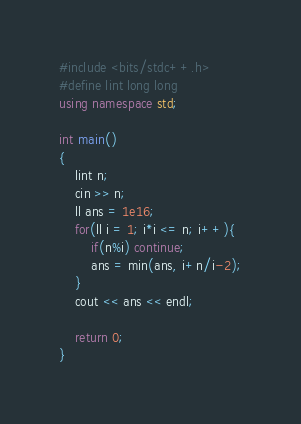Convert code to text. <code><loc_0><loc_0><loc_500><loc_500><_C++_>#include <bits/stdc++.h>
#define lint long long
using namespace std;
 
int main()
{
    lint n;
    cin >> n;
    ll ans = 1e16;
    for(ll i = 1; i*i <= n; i++){
        if(n%i) continue;
        ans = min(ans, i+n/i-2);
    }
    cout << ans << endl;
 
    return 0;
}
</code> 